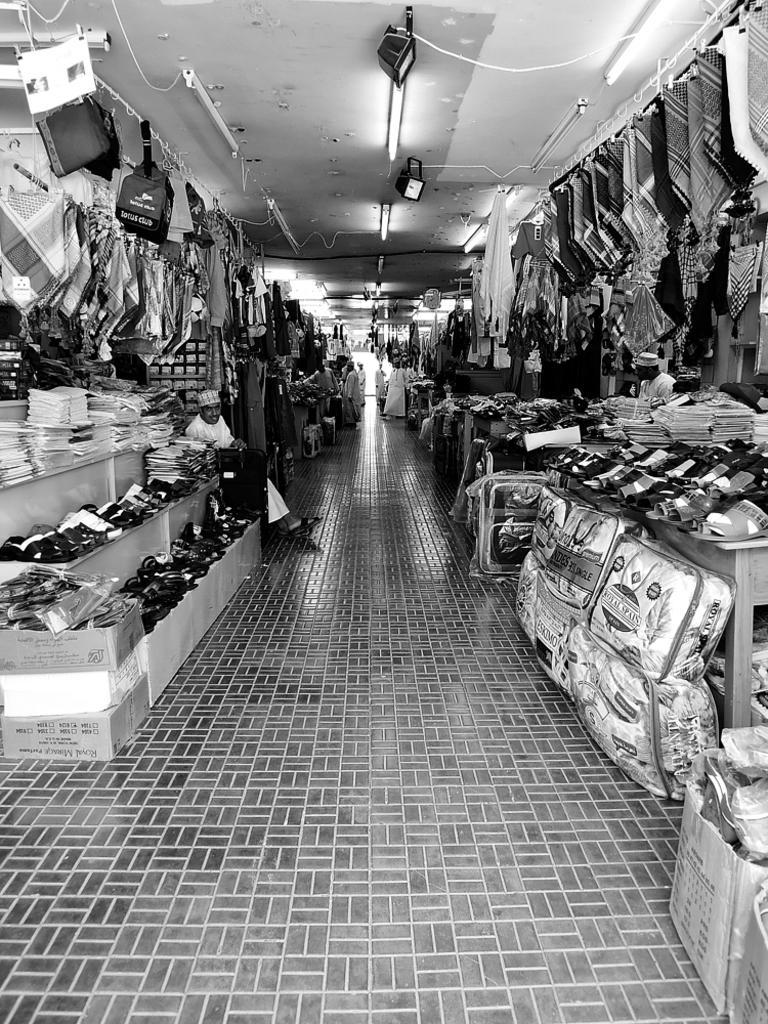How would you summarize this image in a sentence or two? On the left side, there are some objects arranged on the shelves and there is a person sitting. On the right side, there are some objects arranged on the tables and there are bags arranged on the floor. In the background, there are persons and there are lights attached to the roof. 